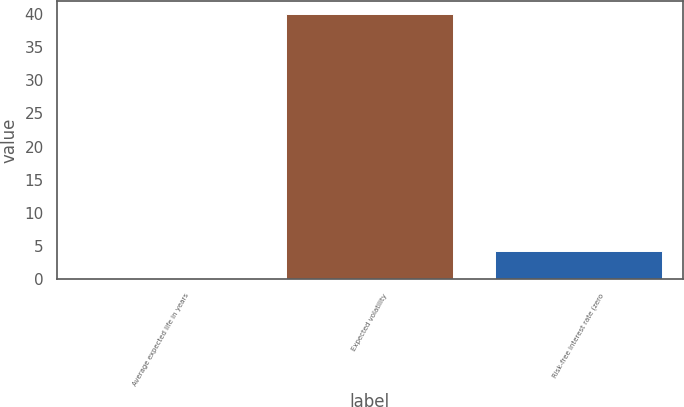Convert chart. <chart><loc_0><loc_0><loc_500><loc_500><bar_chart><fcel>Average expected life in years<fcel>Expected volatility<fcel>Risk-free interest rate (zero<nl><fcel>0.25<fcel>40<fcel>4.22<nl></chart> 